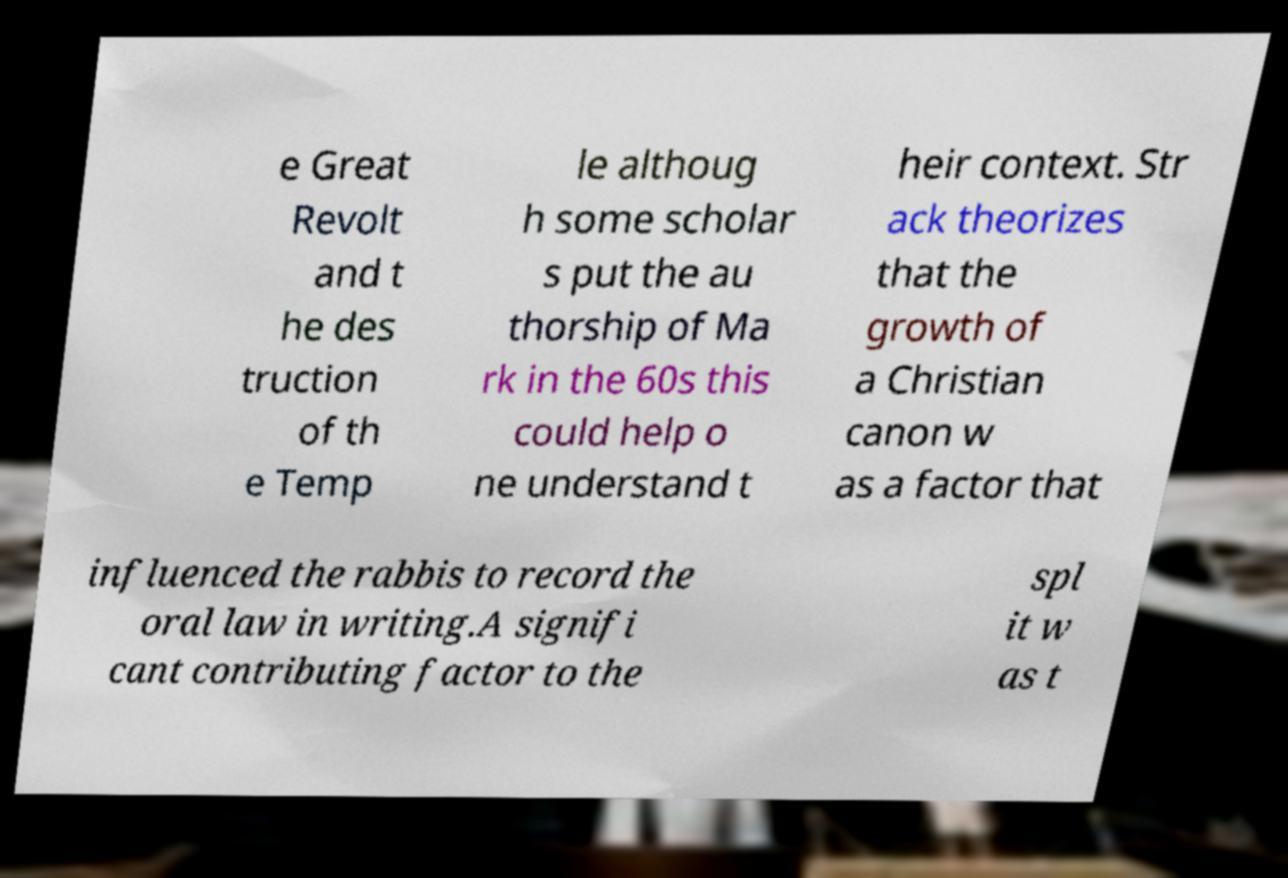There's text embedded in this image that I need extracted. Can you transcribe it verbatim? e Great Revolt and t he des truction of th e Temp le althoug h some scholar s put the au thorship of Ma rk in the 60s this could help o ne understand t heir context. Str ack theorizes that the growth of a Christian canon w as a factor that influenced the rabbis to record the oral law in writing.A signifi cant contributing factor to the spl it w as t 